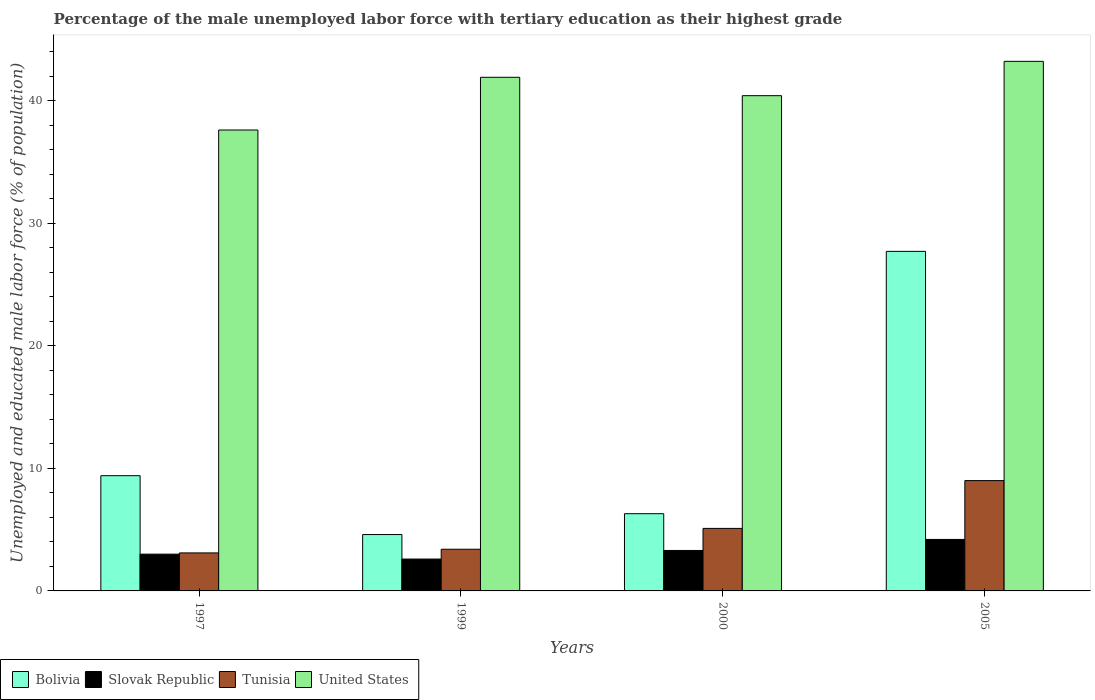How many different coloured bars are there?
Keep it short and to the point. 4. Are the number of bars per tick equal to the number of legend labels?
Provide a succinct answer. Yes. How many bars are there on the 4th tick from the left?
Offer a terse response. 4. How many bars are there on the 2nd tick from the right?
Ensure brevity in your answer.  4. What is the percentage of the unemployed male labor force with tertiary education in Slovak Republic in 2005?
Your answer should be compact. 4.2. Across all years, what is the maximum percentage of the unemployed male labor force with tertiary education in United States?
Your response must be concise. 43.2. Across all years, what is the minimum percentage of the unemployed male labor force with tertiary education in Tunisia?
Ensure brevity in your answer.  3.1. In which year was the percentage of the unemployed male labor force with tertiary education in Slovak Republic minimum?
Your answer should be compact. 1999. What is the total percentage of the unemployed male labor force with tertiary education in Tunisia in the graph?
Your response must be concise. 20.6. What is the difference between the percentage of the unemployed male labor force with tertiary education in United States in 1997 and that in 1999?
Offer a very short reply. -4.3. What is the difference between the percentage of the unemployed male labor force with tertiary education in Slovak Republic in 2000 and the percentage of the unemployed male labor force with tertiary education in United States in 1999?
Your response must be concise. -38.6. What is the average percentage of the unemployed male labor force with tertiary education in United States per year?
Ensure brevity in your answer.  40.78. In the year 1999, what is the difference between the percentage of the unemployed male labor force with tertiary education in Slovak Republic and percentage of the unemployed male labor force with tertiary education in United States?
Keep it short and to the point. -39.3. What is the ratio of the percentage of the unemployed male labor force with tertiary education in Tunisia in 1997 to that in 2000?
Provide a short and direct response. 0.61. What is the difference between the highest and the second highest percentage of the unemployed male labor force with tertiary education in Bolivia?
Provide a succinct answer. 18.3. What is the difference between the highest and the lowest percentage of the unemployed male labor force with tertiary education in Bolivia?
Offer a very short reply. 23.1. In how many years, is the percentage of the unemployed male labor force with tertiary education in United States greater than the average percentage of the unemployed male labor force with tertiary education in United States taken over all years?
Your answer should be very brief. 2. Is the sum of the percentage of the unemployed male labor force with tertiary education in United States in 1997 and 2005 greater than the maximum percentage of the unemployed male labor force with tertiary education in Slovak Republic across all years?
Keep it short and to the point. Yes. What does the 1st bar from the left in 1997 represents?
Keep it short and to the point. Bolivia. What does the 3rd bar from the right in 1999 represents?
Give a very brief answer. Slovak Republic. Is it the case that in every year, the sum of the percentage of the unemployed male labor force with tertiary education in Bolivia and percentage of the unemployed male labor force with tertiary education in Slovak Republic is greater than the percentage of the unemployed male labor force with tertiary education in United States?
Make the answer very short. No. How many bars are there?
Make the answer very short. 16. Are all the bars in the graph horizontal?
Provide a short and direct response. No. Are the values on the major ticks of Y-axis written in scientific E-notation?
Your answer should be compact. No. Does the graph contain any zero values?
Your answer should be compact. No. Does the graph contain grids?
Provide a short and direct response. No. What is the title of the graph?
Your answer should be very brief. Percentage of the male unemployed labor force with tertiary education as their highest grade. Does "Panama" appear as one of the legend labels in the graph?
Give a very brief answer. No. What is the label or title of the Y-axis?
Make the answer very short. Unemployed and educated male labor force (% of population). What is the Unemployed and educated male labor force (% of population) in Bolivia in 1997?
Offer a terse response. 9.4. What is the Unemployed and educated male labor force (% of population) in Slovak Republic in 1997?
Ensure brevity in your answer.  3. What is the Unemployed and educated male labor force (% of population) in Tunisia in 1997?
Keep it short and to the point. 3.1. What is the Unemployed and educated male labor force (% of population) in United States in 1997?
Offer a very short reply. 37.6. What is the Unemployed and educated male labor force (% of population) in Bolivia in 1999?
Offer a very short reply. 4.6. What is the Unemployed and educated male labor force (% of population) of Slovak Republic in 1999?
Give a very brief answer. 2.6. What is the Unemployed and educated male labor force (% of population) in Tunisia in 1999?
Your response must be concise. 3.4. What is the Unemployed and educated male labor force (% of population) in United States in 1999?
Your answer should be compact. 41.9. What is the Unemployed and educated male labor force (% of population) in Bolivia in 2000?
Keep it short and to the point. 6.3. What is the Unemployed and educated male labor force (% of population) in Slovak Republic in 2000?
Give a very brief answer. 3.3. What is the Unemployed and educated male labor force (% of population) in Tunisia in 2000?
Give a very brief answer. 5.1. What is the Unemployed and educated male labor force (% of population) of United States in 2000?
Offer a terse response. 40.4. What is the Unemployed and educated male labor force (% of population) in Bolivia in 2005?
Provide a short and direct response. 27.7. What is the Unemployed and educated male labor force (% of population) of Slovak Republic in 2005?
Your answer should be compact. 4.2. What is the Unemployed and educated male labor force (% of population) in Tunisia in 2005?
Your answer should be compact. 9. What is the Unemployed and educated male labor force (% of population) of United States in 2005?
Your answer should be compact. 43.2. Across all years, what is the maximum Unemployed and educated male labor force (% of population) of Bolivia?
Give a very brief answer. 27.7. Across all years, what is the maximum Unemployed and educated male labor force (% of population) in Slovak Republic?
Make the answer very short. 4.2. Across all years, what is the maximum Unemployed and educated male labor force (% of population) of Tunisia?
Your response must be concise. 9. Across all years, what is the maximum Unemployed and educated male labor force (% of population) in United States?
Offer a terse response. 43.2. Across all years, what is the minimum Unemployed and educated male labor force (% of population) in Bolivia?
Offer a terse response. 4.6. Across all years, what is the minimum Unemployed and educated male labor force (% of population) of Slovak Republic?
Provide a short and direct response. 2.6. Across all years, what is the minimum Unemployed and educated male labor force (% of population) in Tunisia?
Your answer should be very brief. 3.1. Across all years, what is the minimum Unemployed and educated male labor force (% of population) of United States?
Keep it short and to the point. 37.6. What is the total Unemployed and educated male labor force (% of population) of Slovak Republic in the graph?
Offer a very short reply. 13.1. What is the total Unemployed and educated male labor force (% of population) of Tunisia in the graph?
Give a very brief answer. 20.6. What is the total Unemployed and educated male labor force (% of population) in United States in the graph?
Provide a succinct answer. 163.1. What is the difference between the Unemployed and educated male labor force (% of population) in Bolivia in 1997 and that in 1999?
Provide a succinct answer. 4.8. What is the difference between the Unemployed and educated male labor force (% of population) in Slovak Republic in 1997 and that in 1999?
Your answer should be compact. 0.4. What is the difference between the Unemployed and educated male labor force (% of population) of United States in 1997 and that in 1999?
Offer a very short reply. -4.3. What is the difference between the Unemployed and educated male labor force (% of population) of Bolivia in 1997 and that in 2000?
Your answer should be compact. 3.1. What is the difference between the Unemployed and educated male labor force (% of population) in Slovak Republic in 1997 and that in 2000?
Your answer should be compact. -0.3. What is the difference between the Unemployed and educated male labor force (% of population) of United States in 1997 and that in 2000?
Ensure brevity in your answer.  -2.8. What is the difference between the Unemployed and educated male labor force (% of population) of Bolivia in 1997 and that in 2005?
Your response must be concise. -18.3. What is the difference between the Unemployed and educated male labor force (% of population) in Slovak Republic in 1997 and that in 2005?
Keep it short and to the point. -1.2. What is the difference between the Unemployed and educated male labor force (% of population) in Tunisia in 1997 and that in 2005?
Your response must be concise. -5.9. What is the difference between the Unemployed and educated male labor force (% of population) of Bolivia in 1999 and that in 2000?
Offer a very short reply. -1.7. What is the difference between the Unemployed and educated male labor force (% of population) of United States in 1999 and that in 2000?
Your answer should be compact. 1.5. What is the difference between the Unemployed and educated male labor force (% of population) in Bolivia in 1999 and that in 2005?
Give a very brief answer. -23.1. What is the difference between the Unemployed and educated male labor force (% of population) in Slovak Republic in 1999 and that in 2005?
Offer a very short reply. -1.6. What is the difference between the Unemployed and educated male labor force (% of population) in Tunisia in 1999 and that in 2005?
Your response must be concise. -5.6. What is the difference between the Unemployed and educated male labor force (% of population) of Bolivia in 2000 and that in 2005?
Your answer should be very brief. -21.4. What is the difference between the Unemployed and educated male labor force (% of population) of United States in 2000 and that in 2005?
Provide a succinct answer. -2.8. What is the difference between the Unemployed and educated male labor force (% of population) of Bolivia in 1997 and the Unemployed and educated male labor force (% of population) of United States in 1999?
Make the answer very short. -32.5. What is the difference between the Unemployed and educated male labor force (% of population) of Slovak Republic in 1997 and the Unemployed and educated male labor force (% of population) of United States in 1999?
Give a very brief answer. -38.9. What is the difference between the Unemployed and educated male labor force (% of population) in Tunisia in 1997 and the Unemployed and educated male labor force (% of population) in United States in 1999?
Provide a succinct answer. -38.8. What is the difference between the Unemployed and educated male labor force (% of population) of Bolivia in 1997 and the Unemployed and educated male labor force (% of population) of United States in 2000?
Provide a short and direct response. -31. What is the difference between the Unemployed and educated male labor force (% of population) in Slovak Republic in 1997 and the Unemployed and educated male labor force (% of population) in United States in 2000?
Keep it short and to the point. -37.4. What is the difference between the Unemployed and educated male labor force (% of population) in Tunisia in 1997 and the Unemployed and educated male labor force (% of population) in United States in 2000?
Your answer should be very brief. -37.3. What is the difference between the Unemployed and educated male labor force (% of population) in Bolivia in 1997 and the Unemployed and educated male labor force (% of population) in Slovak Republic in 2005?
Ensure brevity in your answer.  5.2. What is the difference between the Unemployed and educated male labor force (% of population) in Bolivia in 1997 and the Unemployed and educated male labor force (% of population) in United States in 2005?
Provide a short and direct response. -33.8. What is the difference between the Unemployed and educated male labor force (% of population) of Slovak Republic in 1997 and the Unemployed and educated male labor force (% of population) of United States in 2005?
Provide a short and direct response. -40.2. What is the difference between the Unemployed and educated male labor force (% of population) in Tunisia in 1997 and the Unemployed and educated male labor force (% of population) in United States in 2005?
Make the answer very short. -40.1. What is the difference between the Unemployed and educated male labor force (% of population) in Bolivia in 1999 and the Unemployed and educated male labor force (% of population) in Slovak Republic in 2000?
Give a very brief answer. 1.3. What is the difference between the Unemployed and educated male labor force (% of population) in Bolivia in 1999 and the Unemployed and educated male labor force (% of population) in United States in 2000?
Give a very brief answer. -35.8. What is the difference between the Unemployed and educated male labor force (% of population) of Slovak Republic in 1999 and the Unemployed and educated male labor force (% of population) of Tunisia in 2000?
Your answer should be compact. -2.5. What is the difference between the Unemployed and educated male labor force (% of population) in Slovak Republic in 1999 and the Unemployed and educated male labor force (% of population) in United States in 2000?
Offer a terse response. -37.8. What is the difference between the Unemployed and educated male labor force (% of population) of Tunisia in 1999 and the Unemployed and educated male labor force (% of population) of United States in 2000?
Provide a succinct answer. -37. What is the difference between the Unemployed and educated male labor force (% of population) of Bolivia in 1999 and the Unemployed and educated male labor force (% of population) of Slovak Republic in 2005?
Keep it short and to the point. 0.4. What is the difference between the Unemployed and educated male labor force (% of population) in Bolivia in 1999 and the Unemployed and educated male labor force (% of population) in United States in 2005?
Provide a succinct answer. -38.6. What is the difference between the Unemployed and educated male labor force (% of population) of Slovak Republic in 1999 and the Unemployed and educated male labor force (% of population) of United States in 2005?
Provide a succinct answer. -40.6. What is the difference between the Unemployed and educated male labor force (% of population) of Tunisia in 1999 and the Unemployed and educated male labor force (% of population) of United States in 2005?
Make the answer very short. -39.8. What is the difference between the Unemployed and educated male labor force (% of population) of Bolivia in 2000 and the Unemployed and educated male labor force (% of population) of Slovak Republic in 2005?
Give a very brief answer. 2.1. What is the difference between the Unemployed and educated male labor force (% of population) of Bolivia in 2000 and the Unemployed and educated male labor force (% of population) of Tunisia in 2005?
Offer a terse response. -2.7. What is the difference between the Unemployed and educated male labor force (% of population) of Bolivia in 2000 and the Unemployed and educated male labor force (% of population) of United States in 2005?
Give a very brief answer. -36.9. What is the difference between the Unemployed and educated male labor force (% of population) in Slovak Republic in 2000 and the Unemployed and educated male labor force (% of population) in Tunisia in 2005?
Your answer should be very brief. -5.7. What is the difference between the Unemployed and educated male labor force (% of population) in Slovak Republic in 2000 and the Unemployed and educated male labor force (% of population) in United States in 2005?
Your answer should be compact. -39.9. What is the difference between the Unemployed and educated male labor force (% of population) of Tunisia in 2000 and the Unemployed and educated male labor force (% of population) of United States in 2005?
Your answer should be very brief. -38.1. What is the average Unemployed and educated male labor force (% of population) of Slovak Republic per year?
Provide a succinct answer. 3.27. What is the average Unemployed and educated male labor force (% of population) in Tunisia per year?
Your answer should be compact. 5.15. What is the average Unemployed and educated male labor force (% of population) in United States per year?
Provide a succinct answer. 40.77. In the year 1997, what is the difference between the Unemployed and educated male labor force (% of population) of Bolivia and Unemployed and educated male labor force (% of population) of Slovak Republic?
Your answer should be compact. 6.4. In the year 1997, what is the difference between the Unemployed and educated male labor force (% of population) of Bolivia and Unemployed and educated male labor force (% of population) of Tunisia?
Your response must be concise. 6.3. In the year 1997, what is the difference between the Unemployed and educated male labor force (% of population) of Bolivia and Unemployed and educated male labor force (% of population) of United States?
Keep it short and to the point. -28.2. In the year 1997, what is the difference between the Unemployed and educated male labor force (% of population) of Slovak Republic and Unemployed and educated male labor force (% of population) of Tunisia?
Offer a very short reply. -0.1. In the year 1997, what is the difference between the Unemployed and educated male labor force (% of population) of Slovak Republic and Unemployed and educated male labor force (% of population) of United States?
Ensure brevity in your answer.  -34.6. In the year 1997, what is the difference between the Unemployed and educated male labor force (% of population) in Tunisia and Unemployed and educated male labor force (% of population) in United States?
Offer a terse response. -34.5. In the year 1999, what is the difference between the Unemployed and educated male labor force (% of population) of Bolivia and Unemployed and educated male labor force (% of population) of Slovak Republic?
Provide a succinct answer. 2. In the year 1999, what is the difference between the Unemployed and educated male labor force (% of population) of Bolivia and Unemployed and educated male labor force (% of population) of Tunisia?
Provide a short and direct response. 1.2. In the year 1999, what is the difference between the Unemployed and educated male labor force (% of population) of Bolivia and Unemployed and educated male labor force (% of population) of United States?
Your answer should be very brief. -37.3. In the year 1999, what is the difference between the Unemployed and educated male labor force (% of population) of Slovak Republic and Unemployed and educated male labor force (% of population) of United States?
Your response must be concise. -39.3. In the year 1999, what is the difference between the Unemployed and educated male labor force (% of population) of Tunisia and Unemployed and educated male labor force (% of population) of United States?
Provide a short and direct response. -38.5. In the year 2000, what is the difference between the Unemployed and educated male labor force (% of population) in Bolivia and Unemployed and educated male labor force (% of population) in United States?
Offer a terse response. -34.1. In the year 2000, what is the difference between the Unemployed and educated male labor force (% of population) of Slovak Republic and Unemployed and educated male labor force (% of population) of United States?
Your response must be concise. -37.1. In the year 2000, what is the difference between the Unemployed and educated male labor force (% of population) of Tunisia and Unemployed and educated male labor force (% of population) of United States?
Provide a short and direct response. -35.3. In the year 2005, what is the difference between the Unemployed and educated male labor force (% of population) in Bolivia and Unemployed and educated male labor force (% of population) in United States?
Provide a succinct answer. -15.5. In the year 2005, what is the difference between the Unemployed and educated male labor force (% of population) in Slovak Republic and Unemployed and educated male labor force (% of population) in United States?
Give a very brief answer. -39. In the year 2005, what is the difference between the Unemployed and educated male labor force (% of population) in Tunisia and Unemployed and educated male labor force (% of population) in United States?
Keep it short and to the point. -34.2. What is the ratio of the Unemployed and educated male labor force (% of population) of Bolivia in 1997 to that in 1999?
Offer a very short reply. 2.04. What is the ratio of the Unemployed and educated male labor force (% of population) in Slovak Republic in 1997 to that in 1999?
Offer a terse response. 1.15. What is the ratio of the Unemployed and educated male labor force (% of population) of Tunisia in 1997 to that in 1999?
Offer a very short reply. 0.91. What is the ratio of the Unemployed and educated male labor force (% of population) in United States in 1997 to that in 1999?
Your answer should be compact. 0.9. What is the ratio of the Unemployed and educated male labor force (% of population) in Bolivia in 1997 to that in 2000?
Your answer should be very brief. 1.49. What is the ratio of the Unemployed and educated male labor force (% of population) of Slovak Republic in 1997 to that in 2000?
Your response must be concise. 0.91. What is the ratio of the Unemployed and educated male labor force (% of population) in Tunisia in 1997 to that in 2000?
Make the answer very short. 0.61. What is the ratio of the Unemployed and educated male labor force (% of population) of United States in 1997 to that in 2000?
Give a very brief answer. 0.93. What is the ratio of the Unemployed and educated male labor force (% of population) in Bolivia in 1997 to that in 2005?
Provide a succinct answer. 0.34. What is the ratio of the Unemployed and educated male labor force (% of population) in Tunisia in 1997 to that in 2005?
Offer a terse response. 0.34. What is the ratio of the Unemployed and educated male labor force (% of population) in United States in 1997 to that in 2005?
Make the answer very short. 0.87. What is the ratio of the Unemployed and educated male labor force (% of population) in Bolivia in 1999 to that in 2000?
Keep it short and to the point. 0.73. What is the ratio of the Unemployed and educated male labor force (% of population) of Slovak Republic in 1999 to that in 2000?
Offer a terse response. 0.79. What is the ratio of the Unemployed and educated male labor force (% of population) in United States in 1999 to that in 2000?
Make the answer very short. 1.04. What is the ratio of the Unemployed and educated male labor force (% of population) in Bolivia in 1999 to that in 2005?
Your answer should be very brief. 0.17. What is the ratio of the Unemployed and educated male labor force (% of population) in Slovak Republic in 1999 to that in 2005?
Provide a succinct answer. 0.62. What is the ratio of the Unemployed and educated male labor force (% of population) of Tunisia in 1999 to that in 2005?
Make the answer very short. 0.38. What is the ratio of the Unemployed and educated male labor force (% of population) of United States in 1999 to that in 2005?
Keep it short and to the point. 0.97. What is the ratio of the Unemployed and educated male labor force (% of population) in Bolivia in 2000 to that in 2005?
Make the answer very short. 0.23. What is the ratio of the Unemployed and educated male labor force (% of population) in Slovak Republic in 2000 to that in 2005?
Ensure brevity in your answer.  0.79. What is the ratio of the Unemployed and educated male labor force (% of population) in Tunisia in 2000 to that in 2005?
Your answer should be very brief. 0.57. What is the ratio of the Unemployed and educated male labor force (% of population) of United States in 2000 to that in 2005?
Your answer should be very brief. 0.94. What is the difference between the highest and the second highest Unemployed and educated male labor force (% of population) of Tunisia?
Provide a succinct answer. 3.9. What is the difference between the highest and the second highest Unemployed and educated male labor force (% of population) in United States?
Your answer should be compact. 1.3. What is the difference between the highest and the lowest Unemployed and educated male labor force (% of population) in Bolivia?
Offer a very short reply. 23.1. What is the difference between the highest and the lowest Unemployed and educated male labor force (% of population) in Slovak Republic?
Offer a terse response. 1.6. What is the difference between the highest and the lowest Unemployed and educated male labor force (% of population) of Tunisia?
Ensure brevity in your answer.  5.9. 